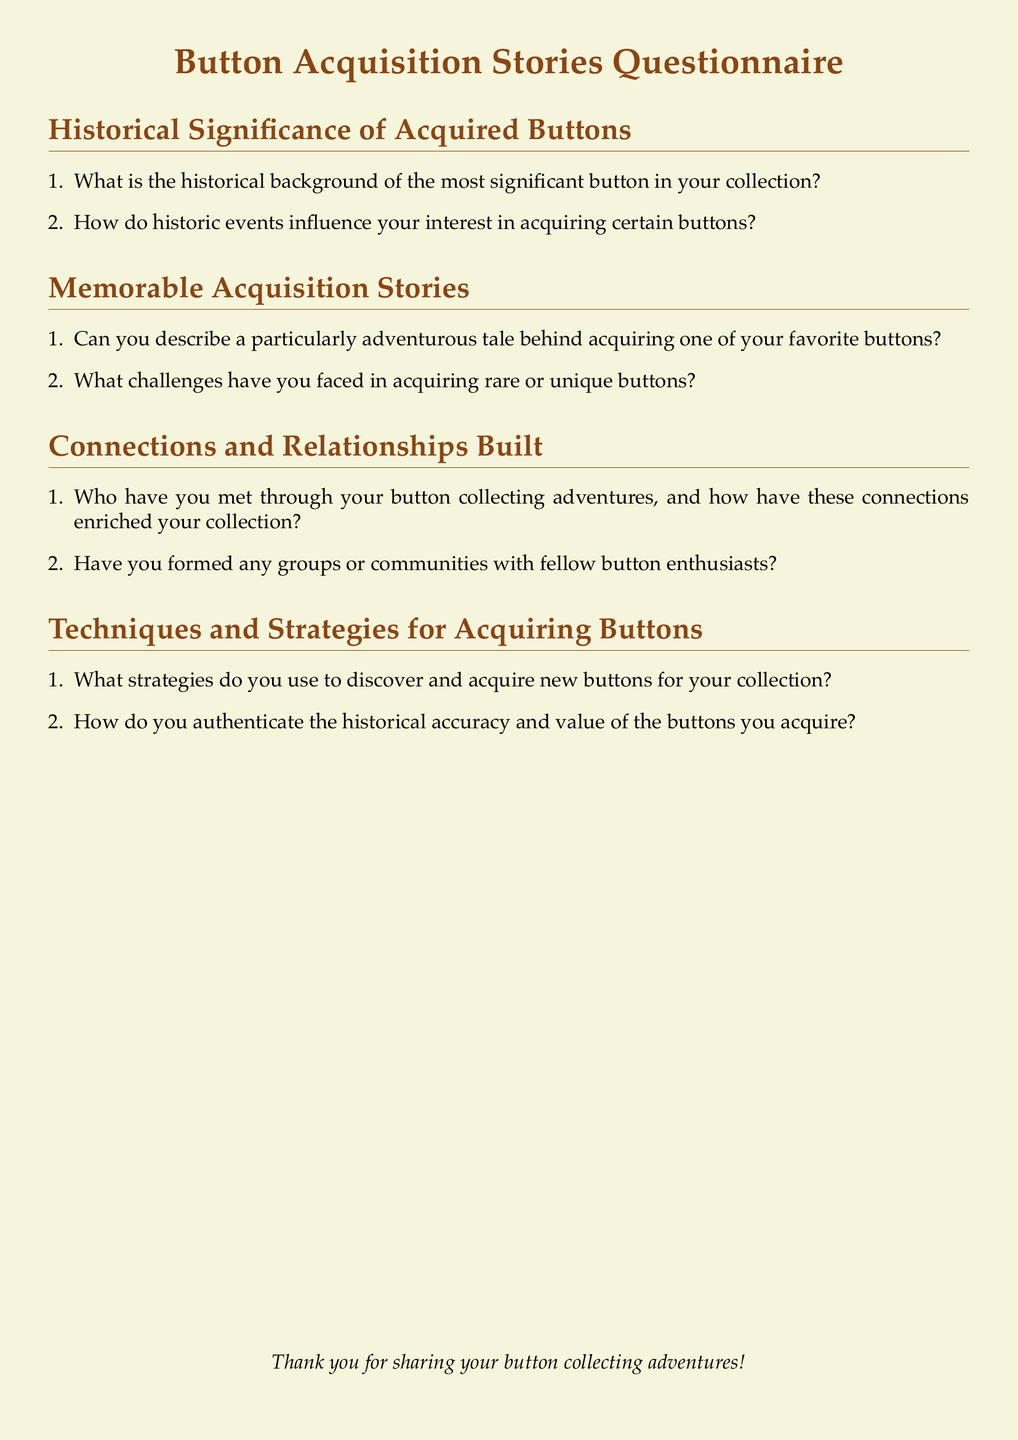What is the title of the document? The title is stated at the beginning of the document and is emphasized in a larger font.
Answer: Button Acquisition Stories Questionnaire How many main sections are in the document? The sections are clearly listed in the document under each title, and counting them reveals their total.
Answer: Four What color is the page background? The document specifies a color in the code that indicates the background color.
Answer: Button beige What is one of the topics covered in the first main section? The first main section has enumerated questions that revolve around a particular theme.
Answer: Historical background How does the document address the connections aspect of button collecting? The document has a distinct section dedicated to discussing relationships built through collecting.
Answer: Connections and Relationships Built What type of strategies does the document ask about regarding acquiring buttons? The questionnaire encourages discussing methodologies for obtaining items which are identified early on.
Answer: Techniques and Strategies What is the main purpose of the questionnaire? The document states its intent to gather personal stories and experiences related to button collecting.
Answer: Documenting the Adventures and Tales Which color is used for the section headings? The code outlines a color scheme that identifies the hue used for section titles throughout the text.
Answer: Button brown 